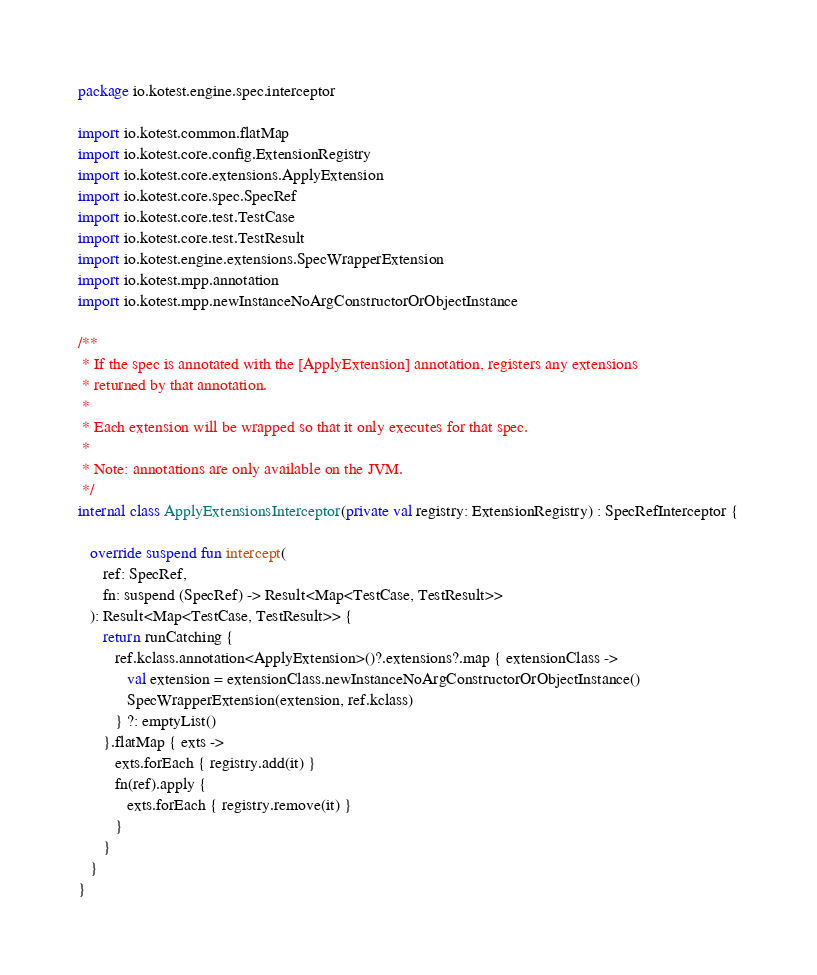<code> <loc_0><loc_0><loc_500><loc_500><_Kotlin_>package io.kotest.engine.spec.interceptor

import io.kotest.common.flatMap
import io.kotest.core.config.ExtensionRegistry
import io.kotest.core.extensions.ApplyExtension
import io.kotest.core.spec.SpecRef
import io.kotest.core.test.TestCase
import io.kotest.core.test.TestResult
import io.kotest.engine.extensions.SpecWrapperExtension
import io.kotest.mpp.annotation
import io.kotest.mpp.newInstanceNoArgConstructorOrObjectInstance

/**
 * If the spec is annotated with the [ApplyExtension] annotation, registers any extensions
 * returned by that annotation.
 *
 * Each extension will be wrapped so that it only executes for that spec.
 *
 * Note: annotations are only available on the JVM.
 */
internal class ApplyExtensionsInterceptor(private val registry: ExtensionRegistry) : SpecRefInterceptor {

   override suspend fun intercept(
      ref: SpecRef,
      fn: suspend (SpecRef) -> Result<Map<TestCase, TestResult>>
   ): Result<Map<TestCase, TestResult>> {
      return runCatching {
         ref.kclass.annotation<ApplyExtension>()?.extensions?.map { extensionClass ->
            val extension = extensionClass.newInstanceNoArgConstructorOrObjectInstance()
            SpecWrapperExtension(extension, ref.kclass)
         } ?: emptyList()
      }.flatMap { exts ->
         exts.forEach { registry.add(it) }
         fn(ref).apply {
            exts.forEach { registry.remove(it) }
         }
      }
   }
}
</code> 